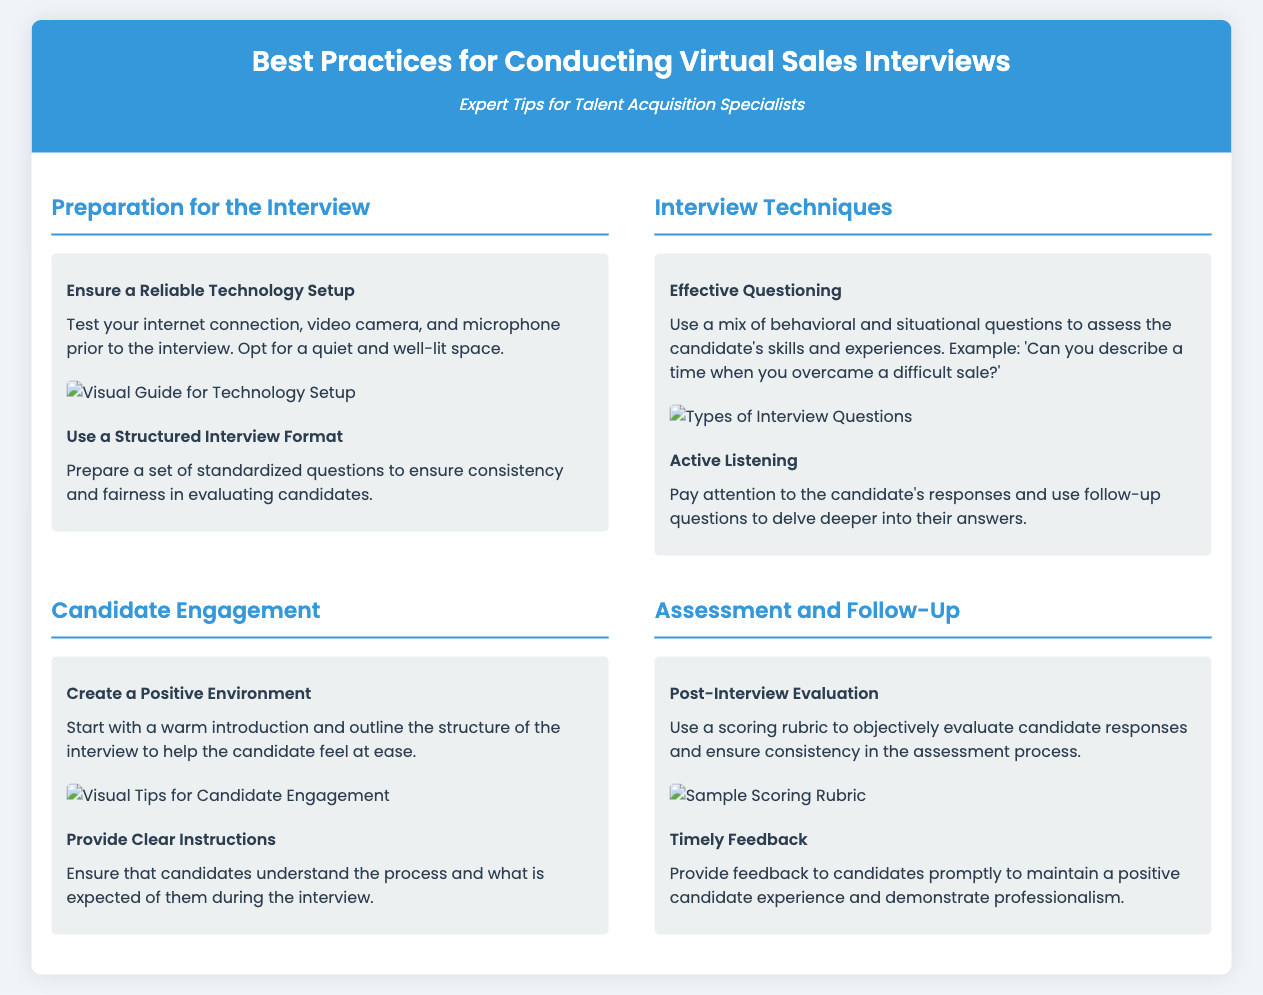What is the main purpose of the flyer? The main purpose of the flyer is to provide expert tips for talent acquisition specialists on conducting virtual sales interviews.
Answer: Expert Tips for Talent Acquisition Specialists What section discusses the importance of technology setup? The section that discusses this is "Preparation for the Interview."
Answer: Preparation for the Interview What type of questions should be used during the interview? The document suggests using a mix of behavioral and situational questions.
Answer: Behavioral and situational questions What is recommended for creating a positive environment? A warm introduction and outlining the structure of the interview is recommended.
Answer: Warm introduction and structure outline What tool should be used for post-interview evaluation? A scoring rubric should be used for the evaluation process.
Answer: Scoring rubric How should feedback be provided to candidates? Feedback should be provided timely to maintain a positive candidate experience.
Answer: Timely What is the main focus of the "Candidate Engagement" section? The main focus is on creating a positive environment and providing clear instructions.
Answer: Positive environment and clear instructions What visual guide is included for technology setup? The visual guide included is "Visual Guide for Technology Setup."
Answer: Visual Guide for Technology Setup What is a key part of "Interview Techniques"? Effective questioning is a key part of Interview Techniques.
Answer: Effective questioning 